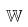<formula> <loc_0><loc_0><loc_500><loc_500>\mathbb { W }</formula> 